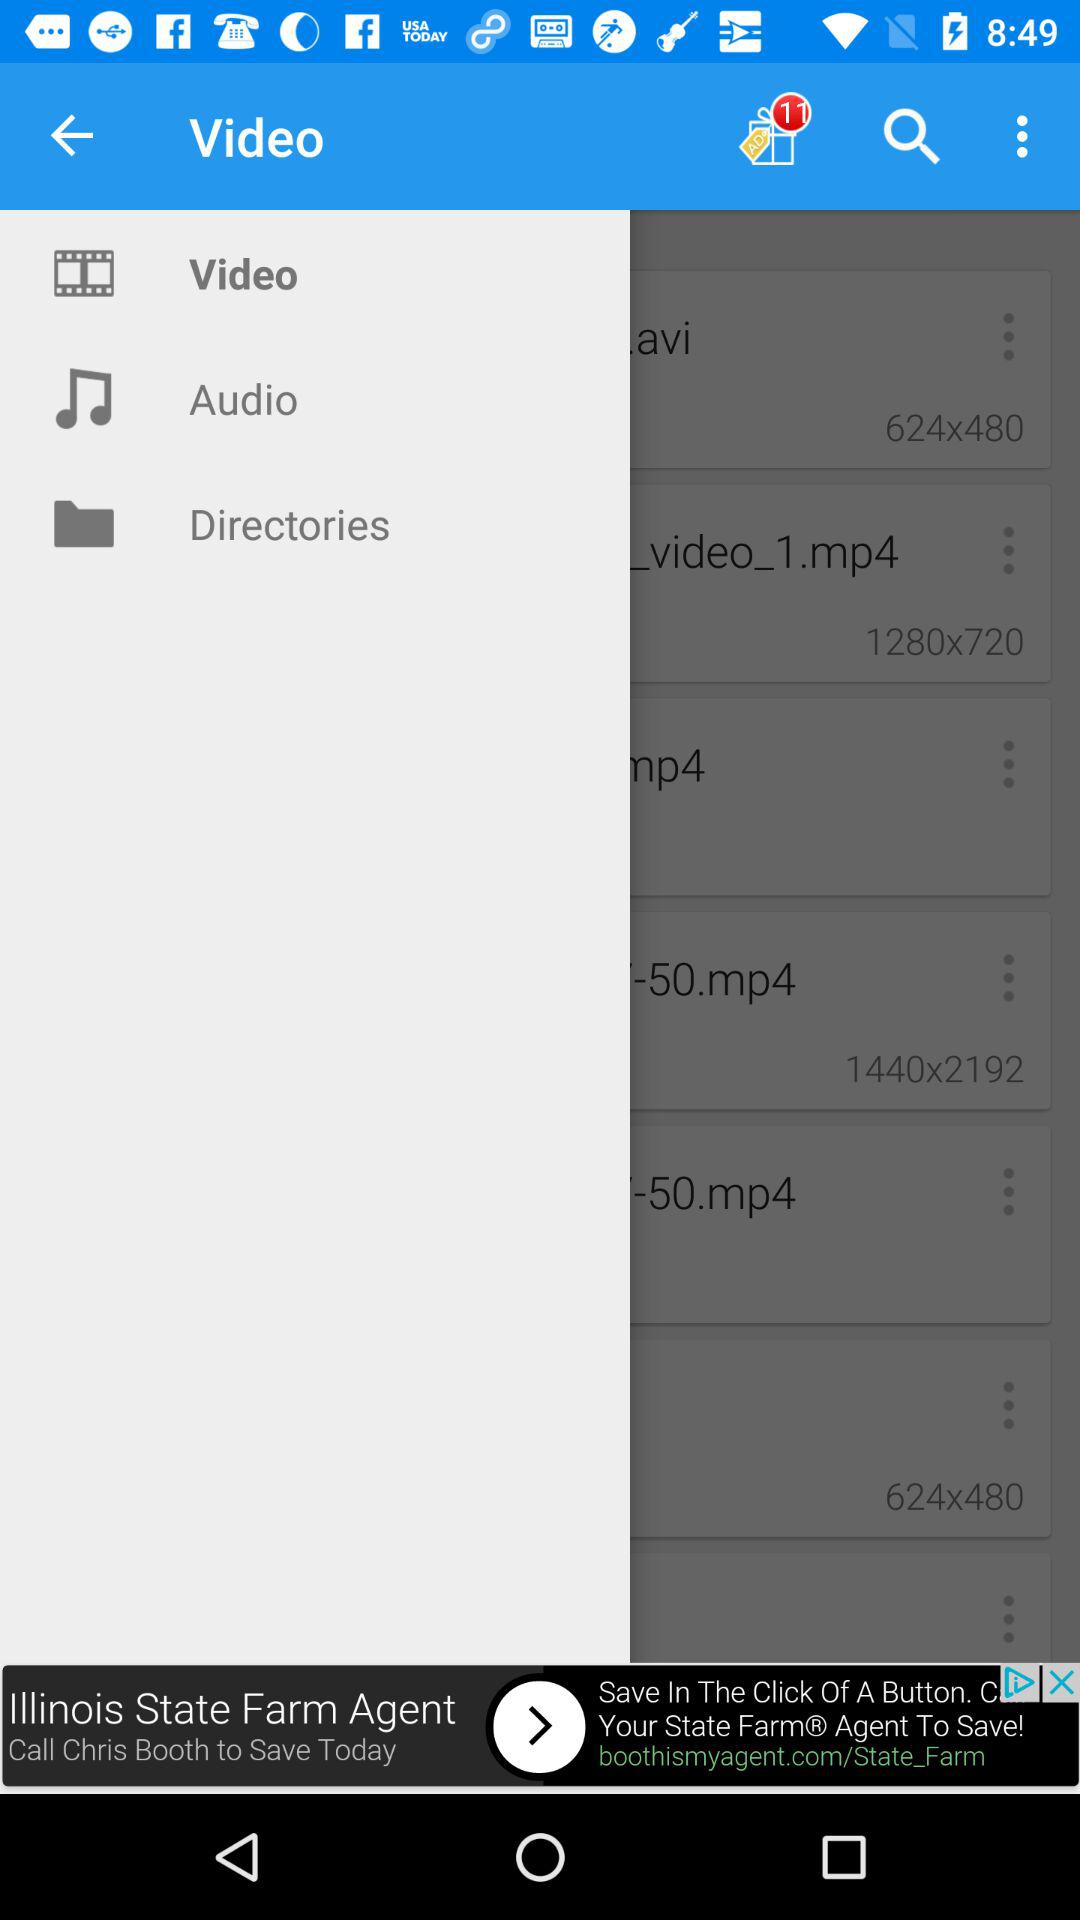How many videos are there?
When the provided information is insufficient, respond with <no answer>. <no answer> 